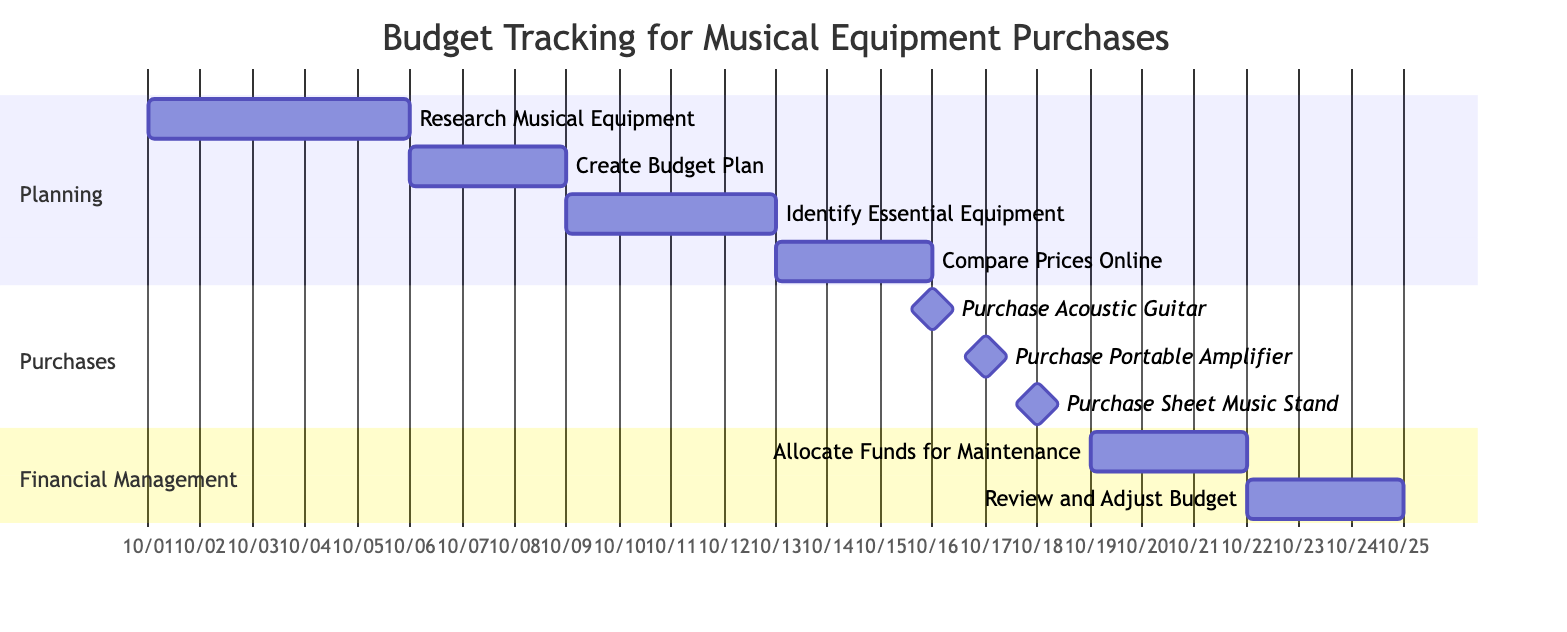What is the duration of the task 'Research Musical Equipment'? The 'Research Musical Equipment' task shows a duration of 5 days, as indicated on the diagram where the task spans from October 1st to October 5th.
Answer: 5 days How many tasks are categorized under 'Purchases'? There are three tasks listed under the 'Purchases' section: 'Purchase Acoustic Guitar', 'Purchase Portable Amplifier', and 'Purchase Sheet Music Stand'.
Answer: 3 tasks What task is scheduled immediately after 'Compare Prices Online'? The task 'Purchase Acoustic Guitar' is scheduled right after 'Compare Prices Online', occurring on October 16th. This can be determined by observing the end date of the comparison task and the subsequent one.
Answer: Purchase Acoustic Guitar What is the start date of the 'Review and Adjust Budget' task? The start date for 'Review and Adjust Budget' is October 22nd, as shown in the diagram where the task is scheduled to begin after the 'Allocate Funds for Maintenance' task concludes.
Answer: October 22 What is the total number of days for all planning tasks? Adding the durations of all planning tasks: Research Musical Equipment (5 days) + Create Budget Plan (3 days) + Identify Essential Equipment (4 days) + Compare Prices Online (3 days) equals 15 days. Therefore, the total is the sum of these durations, which can be verified by visually aggregating each task duration in the planning section.
Answer: 15 days How many days pass between the completion of 'Allocate Funds for Maintenance' and the start of 'Review and Adjust Budget'? 'Allocate Funds for Maintenance' ends on October 21st, and 'Review and Adjust Budget' begins on October 22nd. Thus, there is a gap of 1 day between the end of one task and the start of the next. This is calculated by considering the endpoint and start point of these two tasks.
Answer: 1 day What is the longest task in the planning phase? The 'Research Musical Equipment' task has the longest duration of 5 days compared to the other tasks in the planning phase. Analyzing the durations of tasks in that section shows that it exceeds all others.
Answer: 5 days What is the last task scheduled in the diagram? The last scheduled task in the diagram is 'Review and Adjust Budget', extending until October 24th. This can be seen by checking the last entry in the tasks listed under the 'Financial Management' section.
Answer: Review and Adjust Budget 